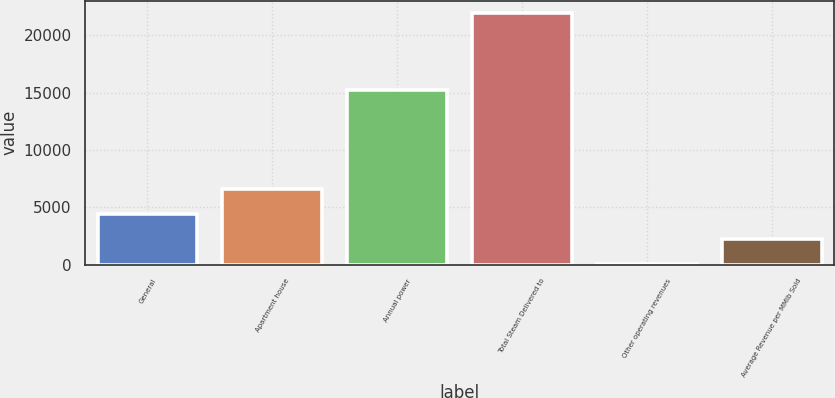Convert chart to OTSL. <chart><loc_0><loc_0><loc_500><loc_500><bar_chart><fcel>General<fcel>Apartment house<fcel>Annual power<fcel>Total Steam Delivered to<fcel>Other operating revenues<fcel>Average Revenue per MMlb Sold<nl><fcel>4405.4<fcel>6595.1<fcel>15195<fcel>21923<fcel>26<fcel>2215.7<nl></chart> 